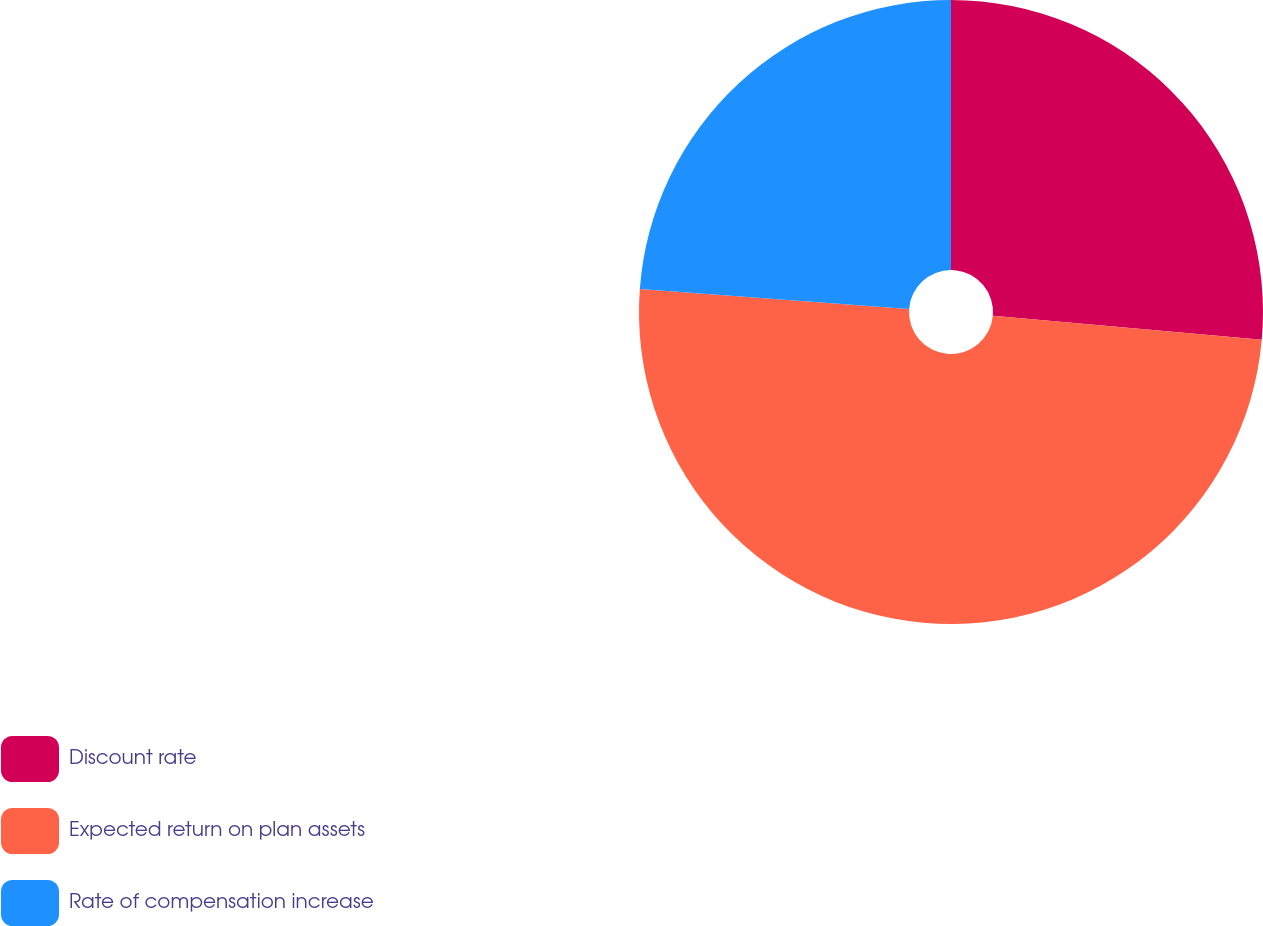Convert chart. <chart><loc_0><loc_0><loc_500><loc_500><pie_chart><fcel>Discount rate<fcel>Expected return on plan assets<fcel>Rate of compensation increase<nl><fcel>26.42%<fcel>49.75%<fcel>23.83%<nl></chart> 